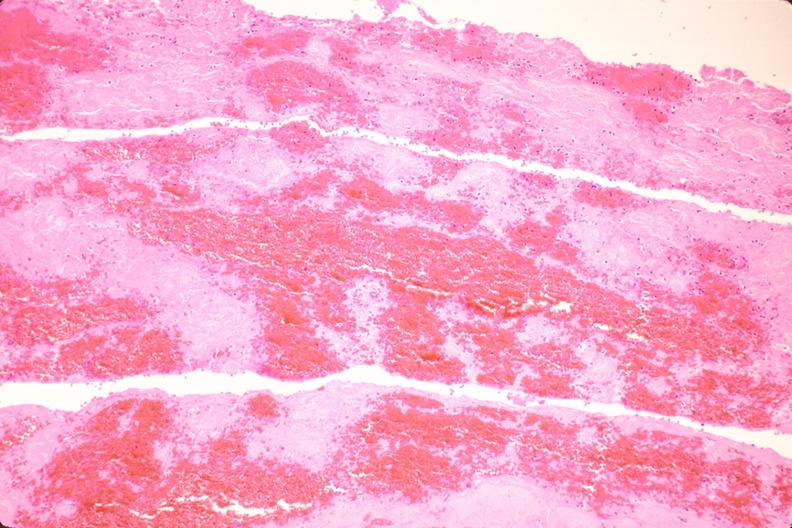where is this from?
Answer the question using a single word or phrase. Vasculature 